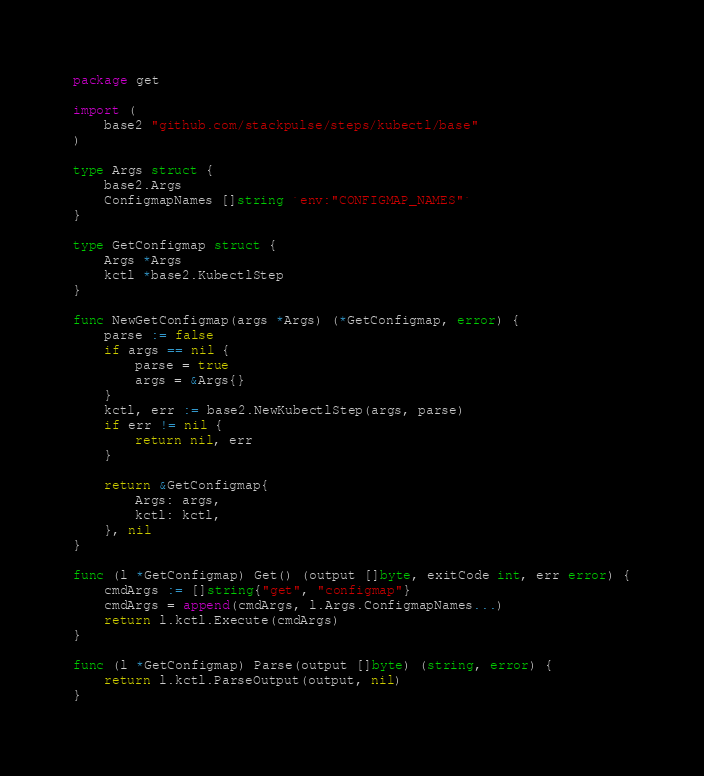Convert code to text. <code><loc_0><loc_0><loc_500><loc_500><_Go_>package get

import (
	base2 "github.com/stackpulse/steps/kubectl/base"
)

type Args struct {
	base2.Args
	ConfigmapNames []string `env:"CONFIGMAP_NAMES"`
}

type GetConfigmap struct {
	Args *Args
	kctl *base2.KubectlStep
}

func NewGetConfigmap(args *Args) (*GetConfigmap, error) {
	parse := false
	if args == nil {
		parse = true
		args = &Args{}
	}
	kctl, err := base2.NewKubectlStep(args, parse)
	if err != nil {
		return nil, err
	}

	return &GetConfigmap{
		Args: args,
		kctl: kctl,
	}, nil
}

func (l *GetConfigmap) Get() (output []byte, exitCode int, err error) {
	cmdArgs := []string{"get", "configmap"}
	cmdArgs = append(cmdArgs, l.Args.ConfigmapNames...)
	return l.kctl.Execute(cmdArgs)
}

func (l *GetConfigmap) Parse(output []byte) (string, error) {
	return l.kctl.ParseOutput(output, nil)
}
</code> 